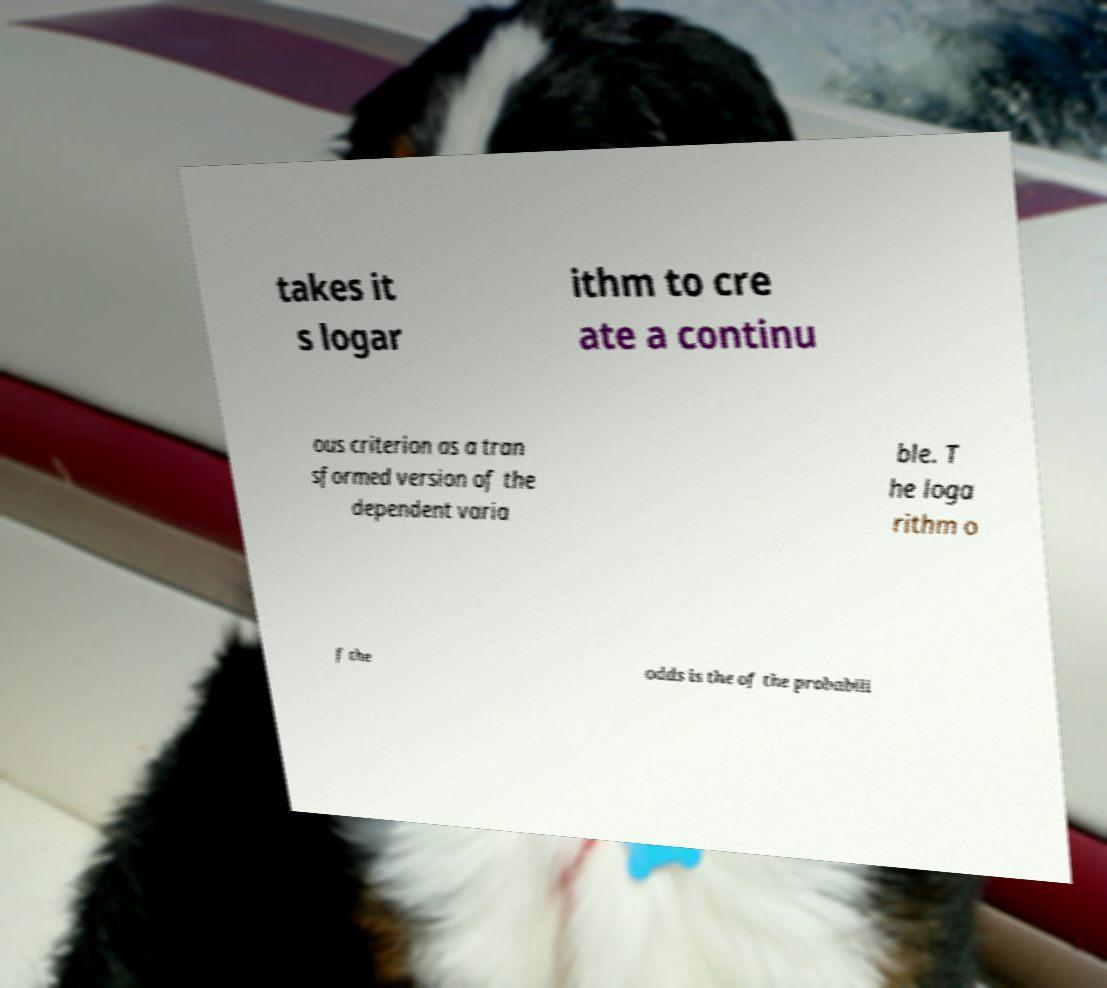Could you extract and type out the text from this image? takes it s logar ithm to cre ate a continu ous criterion as a tran sformed version of the dependent varia ble. T he loga rithm o f the odds is the of the probabili 